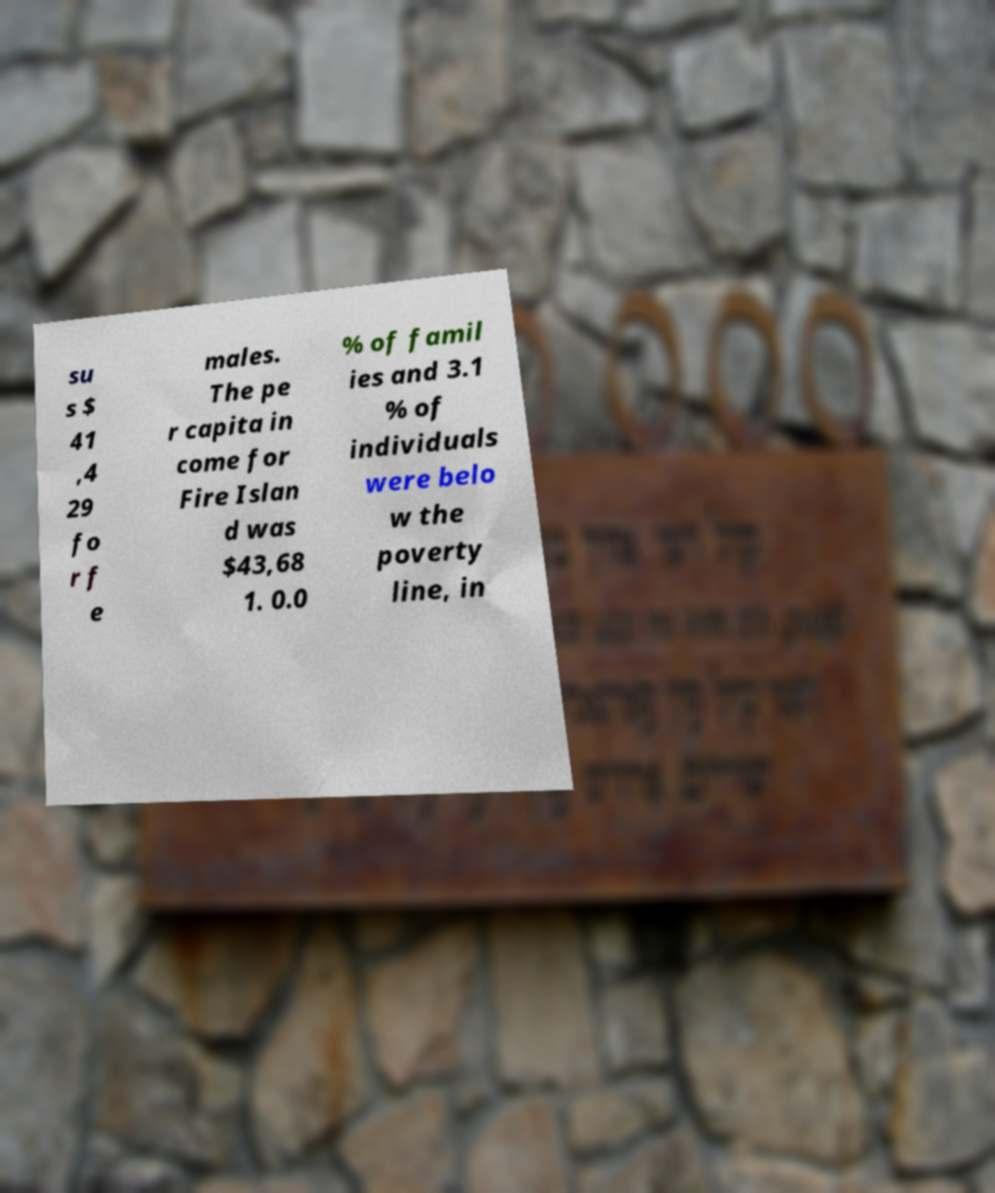Could you assist in decoding the text presented in this image and type it out clearly? su s $ 41 ,4 29 fo r f e males. The pe r capita in come for Fire Islan d was $43,68 1. 0.0 % of famil ies and 3.1 % of individuals were belo w the poverty line, in 